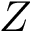<formula> <loc_0><loc_0><loc_500><loc_500>Z</formula> 